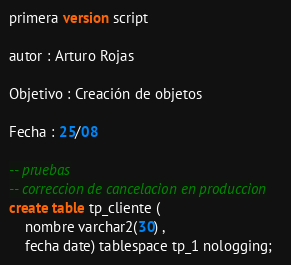Convert code to text. <code><loc_0><loc_0><loc_500><loc_500><_SQL_>
primera version script

autor : Arturo Rojas

Objetivo : Creación de objetos

Fecha : 25/08

-- pruebas
-- correccion de cancelacion en produccion
create table tp_cliente (
	nombre varchar2(30) ,
	fecha date) tablespace tp_1 nologging;
</code> 